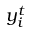Convert formula to latex. <formula><loc_0><loc_0><loc_500><loc_500>y _ { i } ^ { t }</formula> 